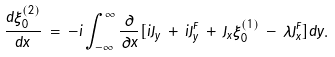Convert formula to latex. <formula><loc_0><loc_0><loc_500><loc_500>\frac { d \xi _ { 0 } ^ { ( 2 ) } } { d x } \, = \, - i \int _ { - \infty } ^ { \infty } \frac { \partial } { \partial x } [ i J _ { y } \, + \, i J _ { y } ^ { F } \, + \, J _ { x } \xi _ { 0 } ^ { ( 1 ) } \, - \, \lambda J _ { x } ^ { F } ] d y .</formula> 